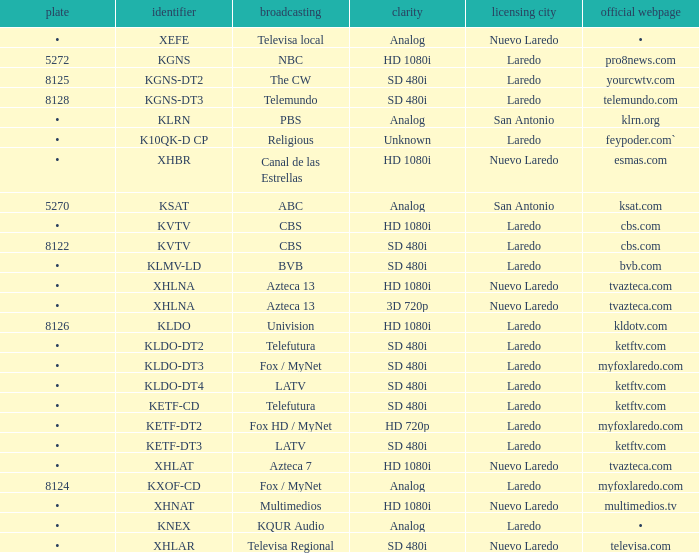Determine the food for 480i sd resolution compatibility and bvb network. •. 